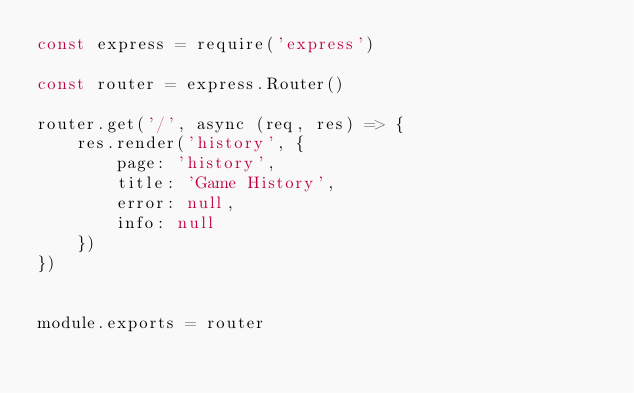Convert code to text. <code><loc_0><loc_0><loc_500><loc_500><_JavaScript_>const express = require('express')

const router = express.Router()

router.get('/', async (req, res) => {
    res.render('history', {
        page: 'history',
        title: 'Game History',
        error: null,
        info: null
    })
})


module.exports = router
</code> 